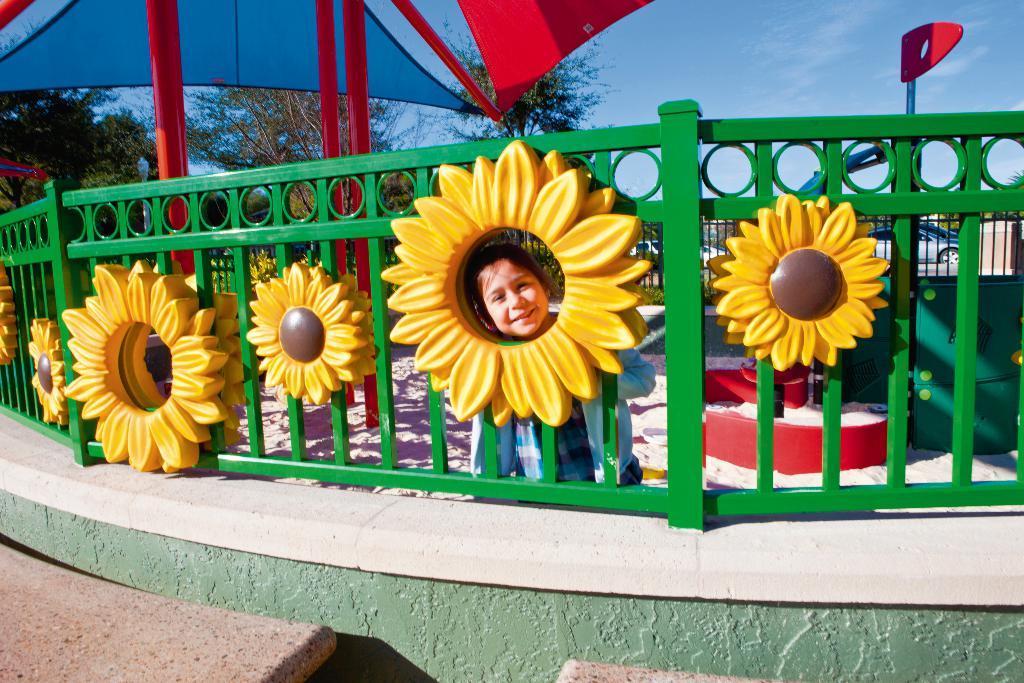Describe this image in one or two sentences. In this picture we can see a child smiling, fence, umbrella, trees, vehicles, some objects and in the background we can see the sky. 